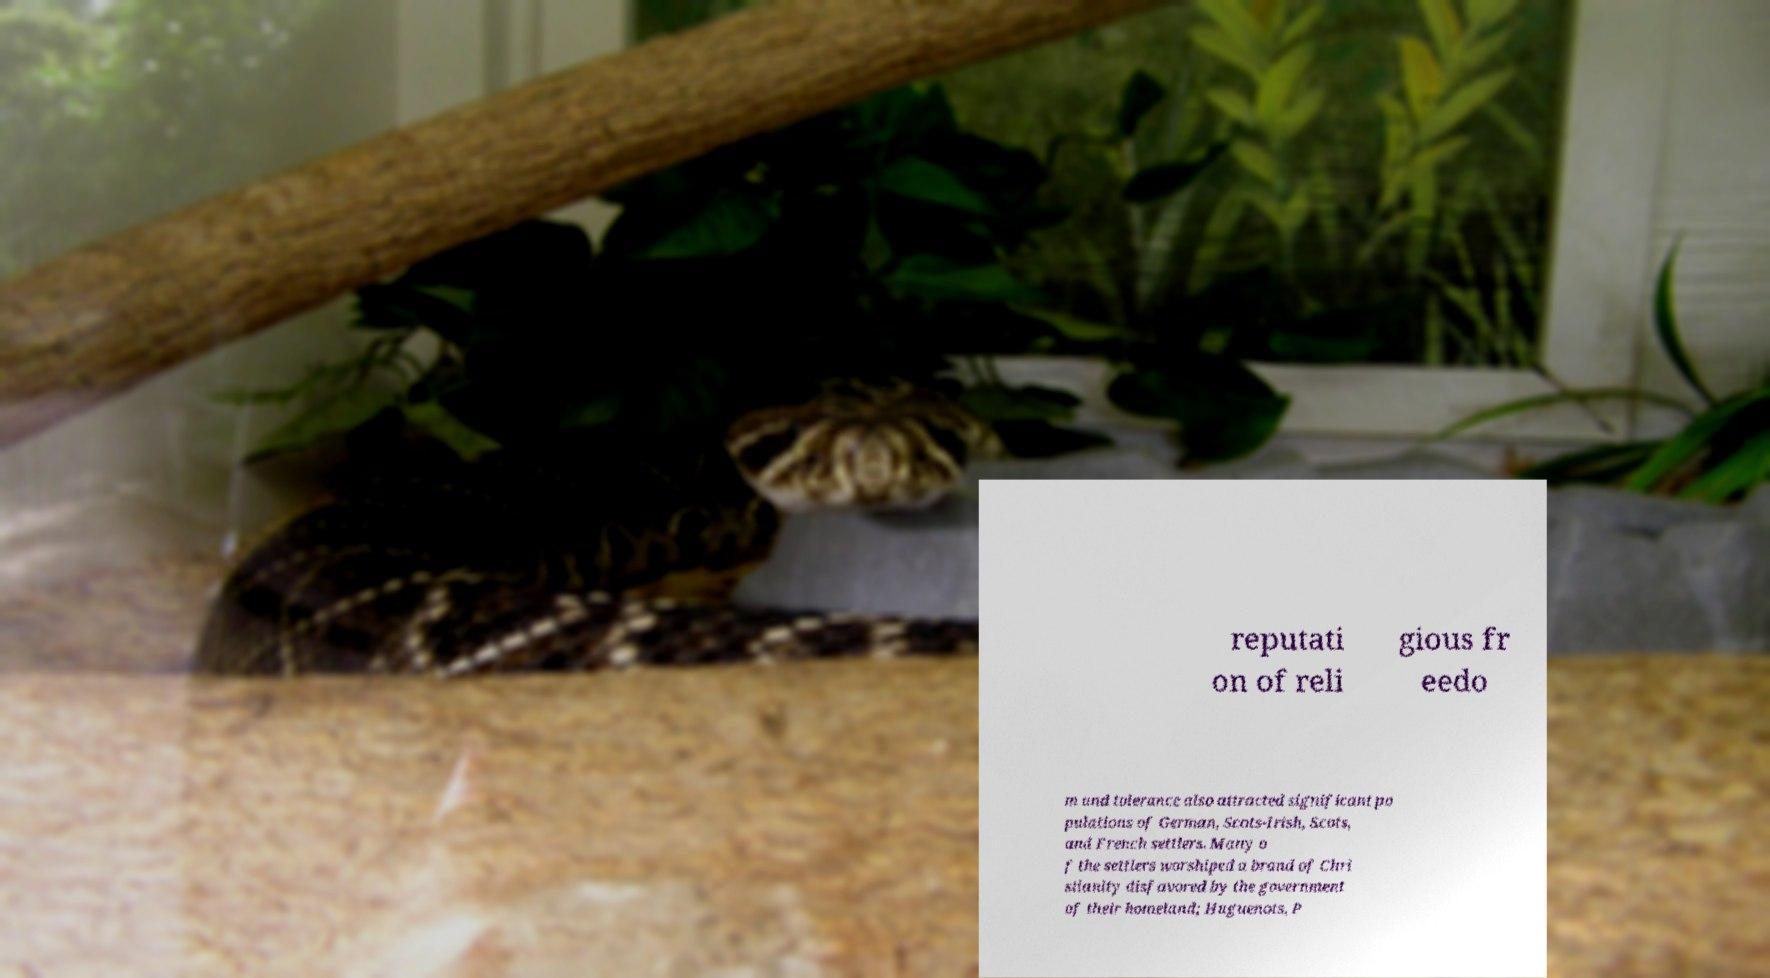Please identify and transcribe the text found in this image. reputati on of reli gious fr eedo m and tolerance also attracted significant po pulations of German, Scots-Irish, Scots, and French settlers. Many o f the settlers worshiped a brand of Chri stianity disfavored by the government of their homeland; Huguenots, P 